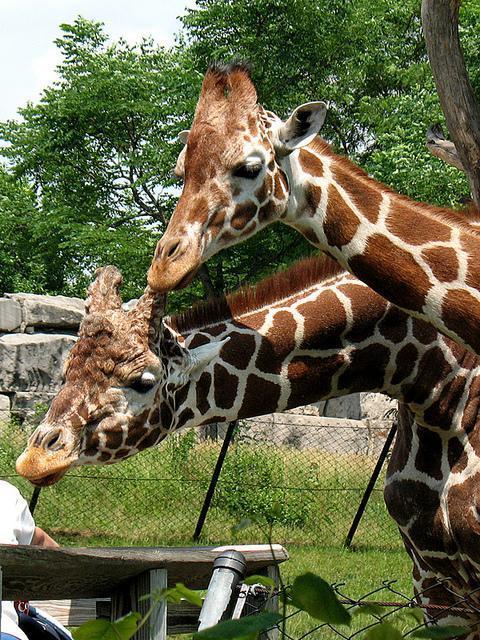How many people are in this picture?
Give a very brief answer. 1. How many giraffes are in the picture?
Give a very brief answer. 2. 